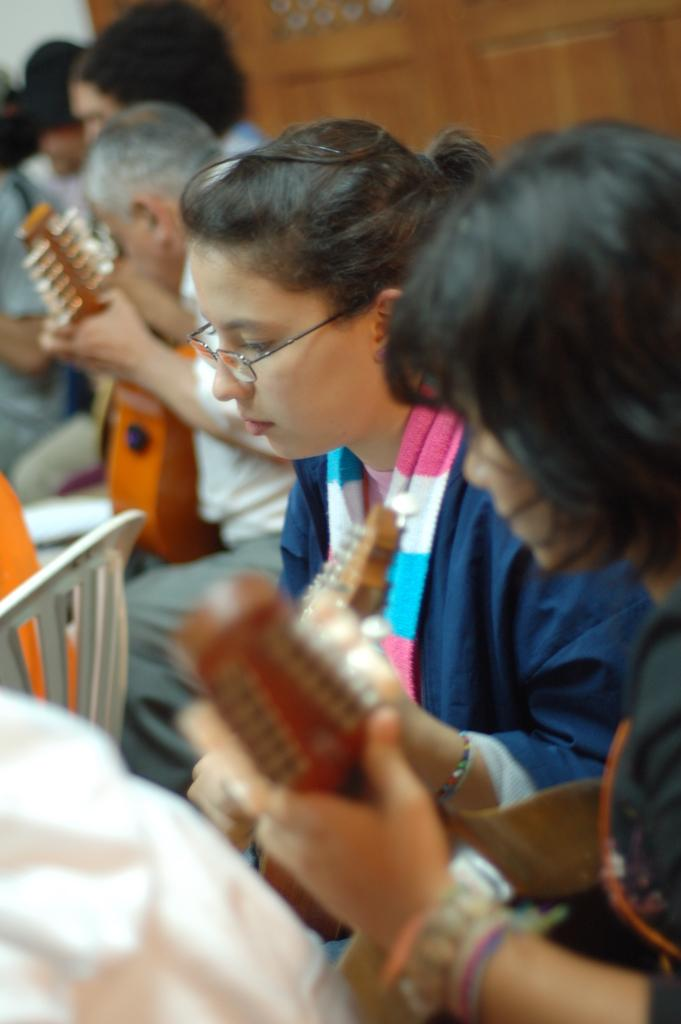What are the people in the image doing? The people in the image are playing musical instruments. Can you describe any background elements in the image? Yes, there is a wooden door in the background of the image. What type of flowers can be seen growing near the camp in the image? There is no camp or flowers present in the image; it features people playing musical instruments and a wooden door in the background. 